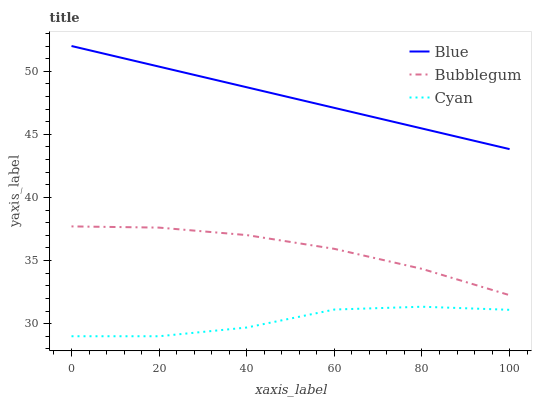Does Cyan have the minimum area under the curve?
Answer yes or no. Yes. Does Blue have the maximum area under the curve?
Answer yes or no. Yes. Does Bubblegum have the minimum area under the curve?
Answer yes or no. No. Does Bubblegum have the maximum area under the curve?
Answer yes or no. No. Is Blue the smoothest?
Answer yes or no. Yes. Is Cyan the roughest?
Answer yes or no. Yes. Is Bubblegum the smoothest?
Answer yes or no. No. Is Bubblegum the roughest?
Answer yes or no. No. Does Cyan have the lowest value?
Answer yes or no. Yes. Does Bubblegum have the lowest value?
Answer yes or no. No. Does Blue have the highest value?
Answer yes or no. Yes. Does Bubblegum have the highest value?
Answer yes or no. No. Is Bubblegum less than Blue?
Answer yes or no. Yes. Is Bubblegum greater than Cyan?
Answer yes or no. Yes. Does Bubblegum intersect Blue?
Answer yes or no. No. 